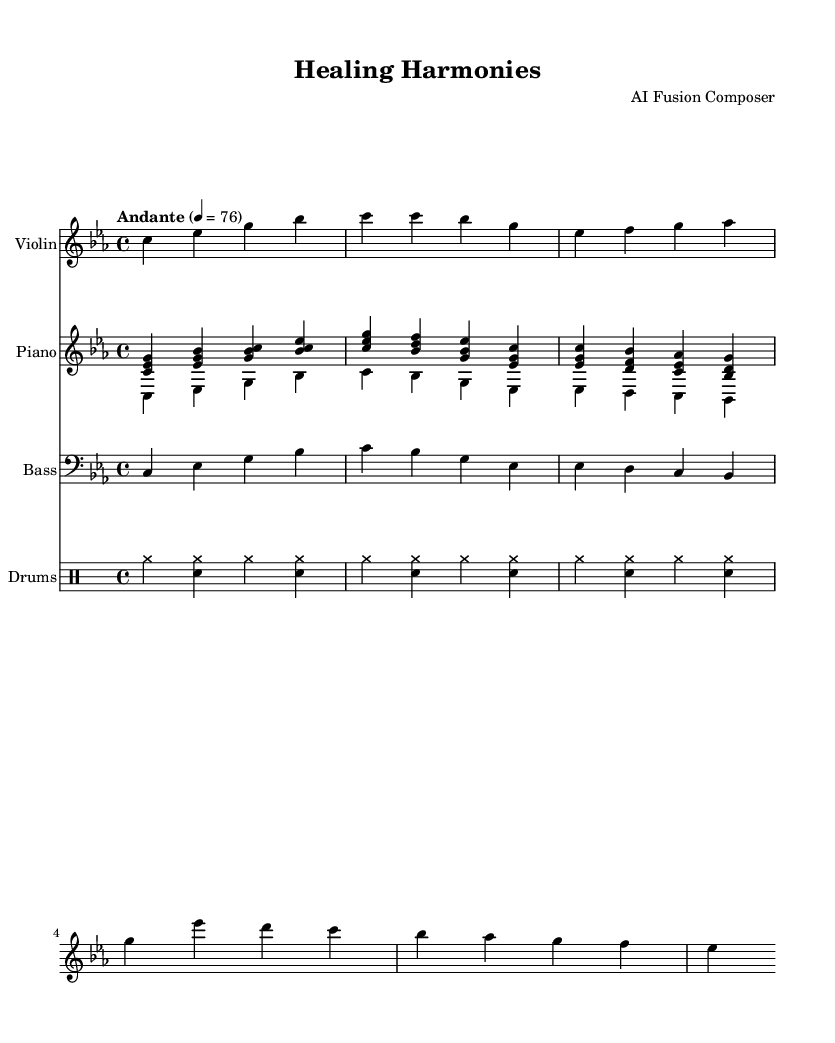What is the key signature of this music? The key signature is C minor, which has three flats (B flat, E flat, and A flat) indicated at the beginning of the staff.
Answer: C minor What is the time signature of this piece? The time signature in the music is 4/4, which means there are four beats in each measure and the quarter note gets one beat, as shown at the beginning of the score.
Answer: 4/4 What is the tempo marking of the composition? The tempo marking is "Andante" with a metronome marking of 76, indicating a moderate pace. This is stated at the beginning of the score.
Answer: Andante How many measures are in Theme A? Theme A consists of four measures, as observed by counting the measures that contain the melody notes specified for Theme A in the violin part.
Answer: Four measures What rhythmic pattern does the drums use? The drums use a basic jazz pattern with brushes, characterized by the specified notation using cymbals and snare. This indicates a typical soft approach for jazz drumming.
Answer: Jazz pattern with brushes In which instrument part is the intro presented? The intro is presented in the violin part where the first few notes are outlined specifically for the instrument at the beginning of the score.
Answer: Violin What type of fusion does this piece represent? This piece represents a fusion of jazz and classical music, which can be inferred from the instrument combination, improvisational aspects, and stylistic elements present in the composition.
Answer: Jazz-classical fusion 